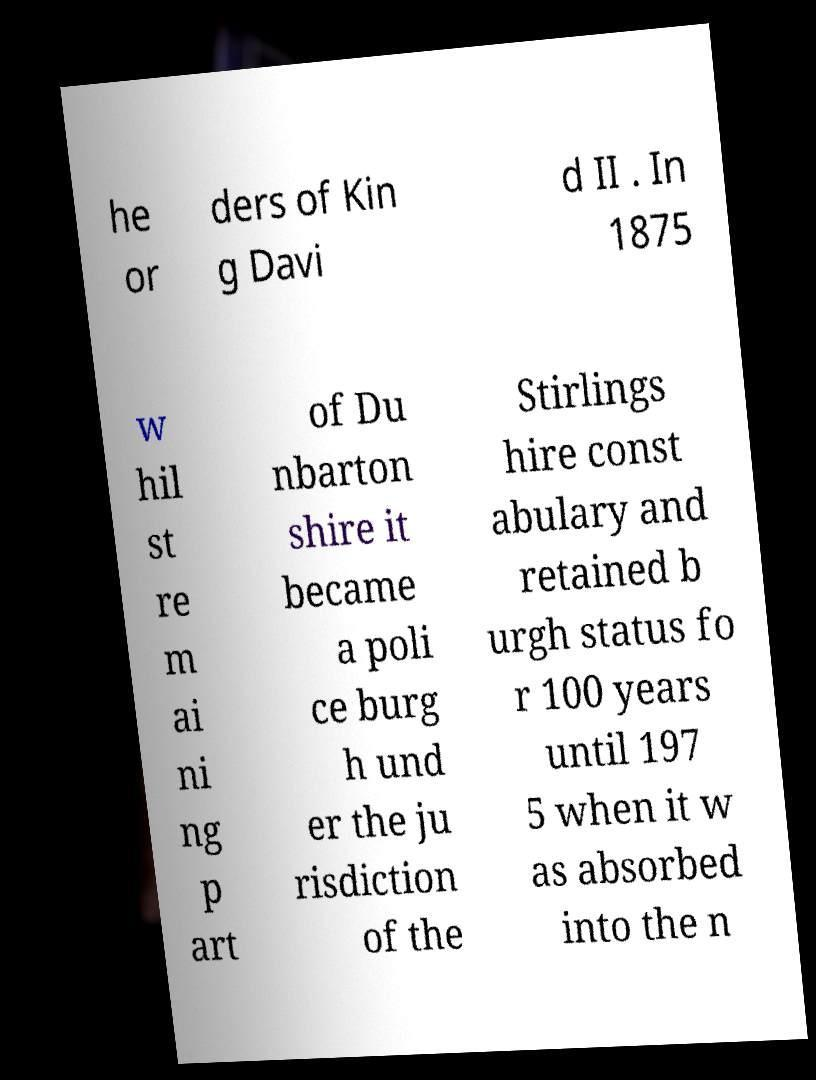Can you accurately transcribe the text from the provided image for me? he or ders of Kin g Davi d II . In 1875 w hil st re m ai ni ng p art of Du nbarton shire it became a poli ce burg h und er the ju risdiction of the Stirlings hire const abulary and retained b urgh status fo r 100 years until 197 5 when it w as absorbed into the n 